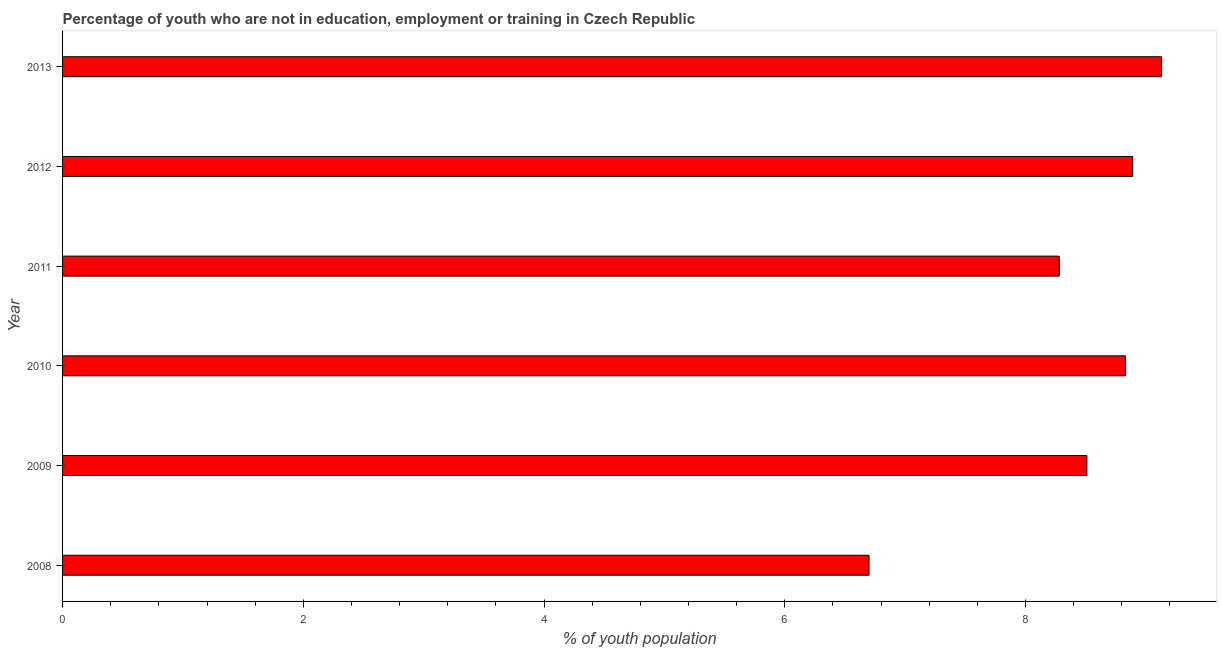Does the graph contain any zero values?
Give a very brief answer. No. What is the title of the graph?
Provide a short and direct response. Percentage of youth who are not in education, employment or training in Czech Republic. What is the label or title of the X-axis?
Provide a short and direct response. % of youth population. What is the unemployed youth population in 2012?
Your answer should be very brief. 8.89. Across all years, what is the maximum unemployed youth population?
Your answer should be very brief. 9.13. Across all years, what is the minimum unemployed youth population?
Your answer should be compact. 6.7. In which year was the unemployed youth population maximum?
Provide a succinct answer. 2013. What is the sum of the unemployed youth population?
Your answer should be compact. 50.34. What is the difference between the unemployed youth population in 2009 and 2010?
Provide a succinct answer. -0.32. What is the average unemployed youth population per year?
Offer a very short reply. 8.39. What is the median unemployed youth population?
Your answer should be very brief. 8.67. What is the ratio of the unemployed youth population in 2008 to that in 2009?
Give a very brief answer. 0.79. What is the difference between the highest and the second highest unemployed youth population?
Provide a succinct answer. 0.24. Is the sum of the unemployed youth population in 2012 and 2013 greater than the maximum unemployed youth population across all years?
Your response must be concise. Yes. What is the difference between the highest and the lowest unemployed youth population?
Provide a short and direct response. 2.43. In how many years, is the unemployed youth population greater than the average unemployed youth population taken over all years?
Offer a very short reply. 4. Are all the bars in the graph horizontal?
Give a very brief answer. Yes. What is the % of youth population in 2008?
Your response must be concise. 6.7. What is the % of youth population in 2009?
Make the answer very short. 8.51. What is the % of youth population of 2010?
Offer a terse response. 8.83. What is the % of youth population of 2011?
Keep it short and to the point. 8.28. What is the % of youth population in 2012?
Provide a short and direct response. 8.89. What is the % of youth population of 2013?
Offer a very short reply. 9.13. What is the difference between the % of youth population in 2008 and 2009?
Ensure brevity in your answer.  -1.81. What is the difference between the % of youth population in 2008 and 2010?
Ensure brevity in your answer.  -2.13. What is the difference between the % of youth population in 2008 and 2011?
Your answer should be very brief. -1.58. What is the difference between the % of youth population in 2008 and 2012?
Provide a succinct answer. -2.19. What is the difference between the % of youth population in 2008 and 2013?
Your response must be concise. -2.43. What is the difference between the % of youth population in 2009 and 2010?
Provide a succinct answer. -0.32. What is the difference between the % of youth population in 2009 and 2011?
Keep it short and to the point. 0.23. What is the difference between the % of youth population in 2009 and 2012?
Your response must be concise. -0.38. What is the difference between the % of youth population in 2009 and 2013?
Provide a succinct answer. -0.62. What is the difference between the % of youth population in 2010 and 2011?
Your answer should be very brief. 0.55. What is the difference between the % of youth population in 2010 and 2012?
Ensure brevity in your answer.  -0.06. What is the difference between the % of youth population in 2011 and 2012?
Offer a very short reply. -0.61. What is the difference between the % of youth population in 2011 and 2013?
Provide a short and direct response. -0.85. What is the difference between the % of youth population in 2012 and 2013?
Make the answer very short. -0.24. What is the ratio of the % of youth population in 2008 to that in 2009?
Give a very brief answer. 0.79. What is the ratio of the % of youth population in 2008 to that in 2010?
Your answer should be compact. 0.76. What is the ratio of the % of youth population in 2008 to that in 2011?
Your response must be concise. 0.81. What is the ratio of the % of youth population in 2008 to that in 2012?
Your answer should be compact. 0.75. What is the ratio of the % of youth population in 2008 to that in 2013?
Make the answer very short. 0.73. What is the ratio of the % of youth population in 2009 to that in 2010?
Give a very brief answer. 0.96. What is the ratio of the % of youth population in 2009 to that in 2011?
Make the answer very short. 1.03. What is the ratio of the % of youth population in 2009 to that in 2013?
Make the answer very short. 0.93. What is the ratio of the % of youth population in 2010 to that in 2011?
Ensure brevity in your answer.  1.07. What is the ratio of the % of youth population in 2010 to that in 2012?
Provide a succinct answer. 0.99. What is the ratio of the % of youth population in 2011 to that in 2012?
Keep it short and to the point. 0.93. What is the ratio of the % of youth population in 2011 to that in 2013?
Your answer should be compact. 0.91. 